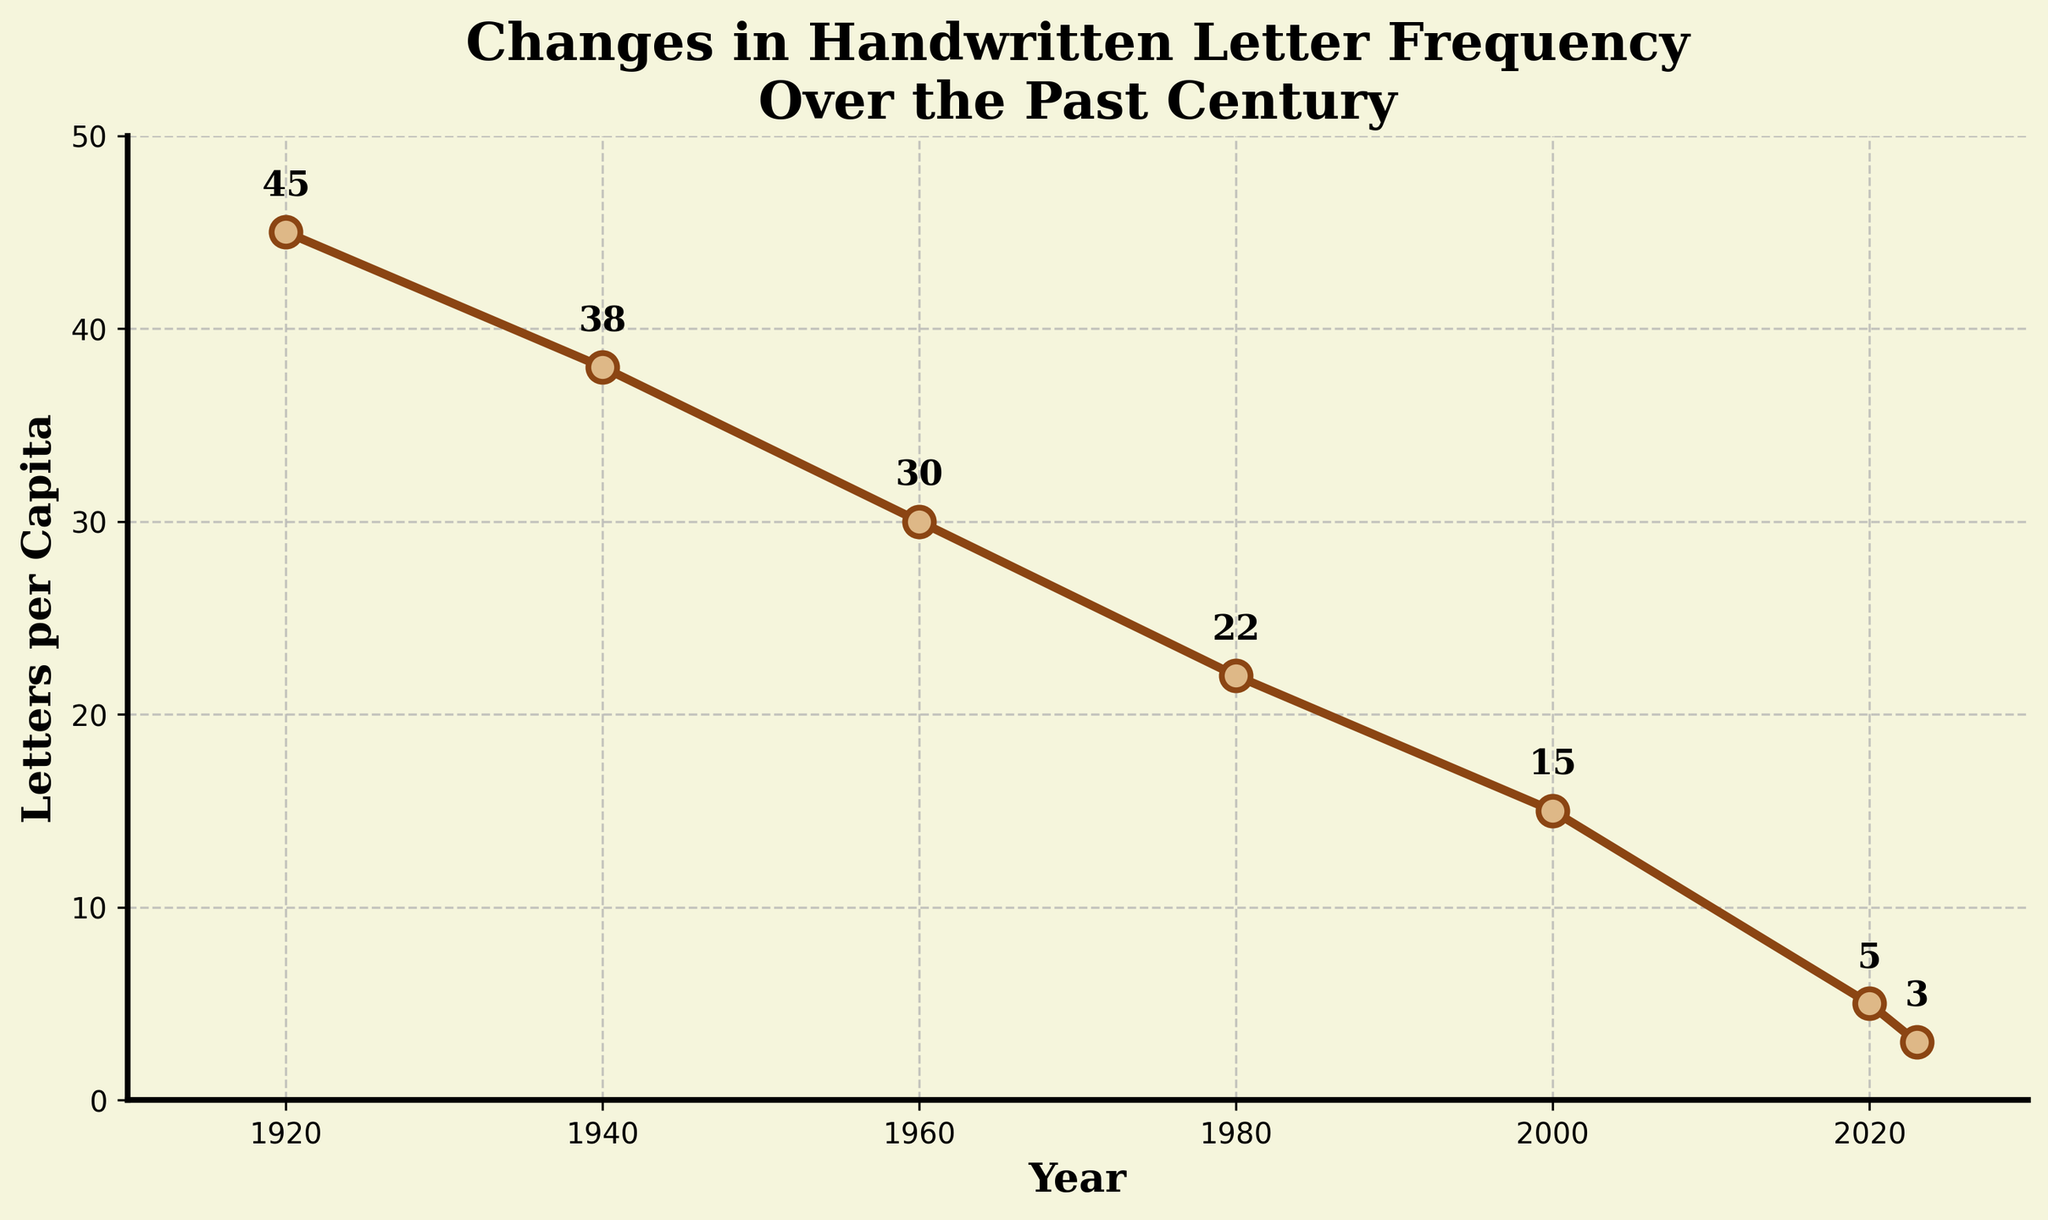What is the trend of handwritten letter exchanges from 1920 to 2023? The figure clearly shows a declining trend in the frequency of handwritten letter exchanges over the years from 1920 to 2023. Starting from 45 letters per capita in 1920, it consistently drops to 3 letters per capita in 2023.
Answer: Declining trend In which year did handwritten letters per capita drop below 10? By observing the plot, handwritten letters per capita dropped below 10 between the year 2000 and 2020. In 2020, the frequency was at 5.
Answer: 2020 What is the total decrease in letters per capita from 1920 to 2023? In 1920, the letters per capita were 45, and by 2023, this decreased to 3. By subtracting the values, 45 - 3, we get the total decrease.
Answer: 42 What is the average number of letters per capita per year across the 20th century data points provided (1920 to 2000)? The data points for the 20th century (1920 to 2000) are 45, 38, 30, 22, and 15. Adding these values gives 45 + 38 + 30 + 22 + 15 = 150. Dividing by the number of data points, we get 150/5 = 30.
Answer: 30 Which year experienced the largest decline in letters per capita when compared to the previous data point? Comparing the declines: 45-38=7 (1920-1940), 38-30=8 (1940-1960), 30-22=8 (1960-1980), 22-15=7 (1980-2000), 15-5=10 (2000-2020), 5-3=2 (2020-2023). The largest single decline is 10, between 2000 and 2020.
Answer: 2000-2020 How many years did it take for the letters per capita to decline from 45 to 5? From 1920 (45 letters per capita) to 2020 (5 letters per capita), it took 100 years (2020-1920).
Answer: 100 years What is the ratio of letters per capita in 1940 compared to 2023? In 1940, there were 38 letters per capita, and in 2023, there were 3. The ratio is calculated as 38/3 ≈ 12.67.
Answer: Approximately 12.67 What is the difference in the number of letters per capita between 1960 and 1980? The letters per capita in 1960 were 30, and in 1980, they were 22. The difference is 30 - 22 = 8.
Answer: 8 Which decade saw the smallest difference in letters per capita between the start and end of the decade? Looking at the changes over each period: 1920-1940: 45-38=7; 1940-1960: 38-30=8; 1960-1980: 30-22=8; 1980-2000: 22-15=7; 2000-2020: 15-5=10. The smallest change is tied between 1920-1940 and 1980-2000, both with a difference of 7.
Answer: 1920-1940 and 1980-2000 What is the overall rate of reduction in letters per capita per year from 1920 to 2023? The total reduction from 1920 to 2023 is 42 letters per capita (45 - 3), over 103 years (2023 - 1920). The rate of reduction per year is 42 / 103 ≈ 0.407 letters per capita per year.
Answer: Approximately 0.407 letters per capita per year 